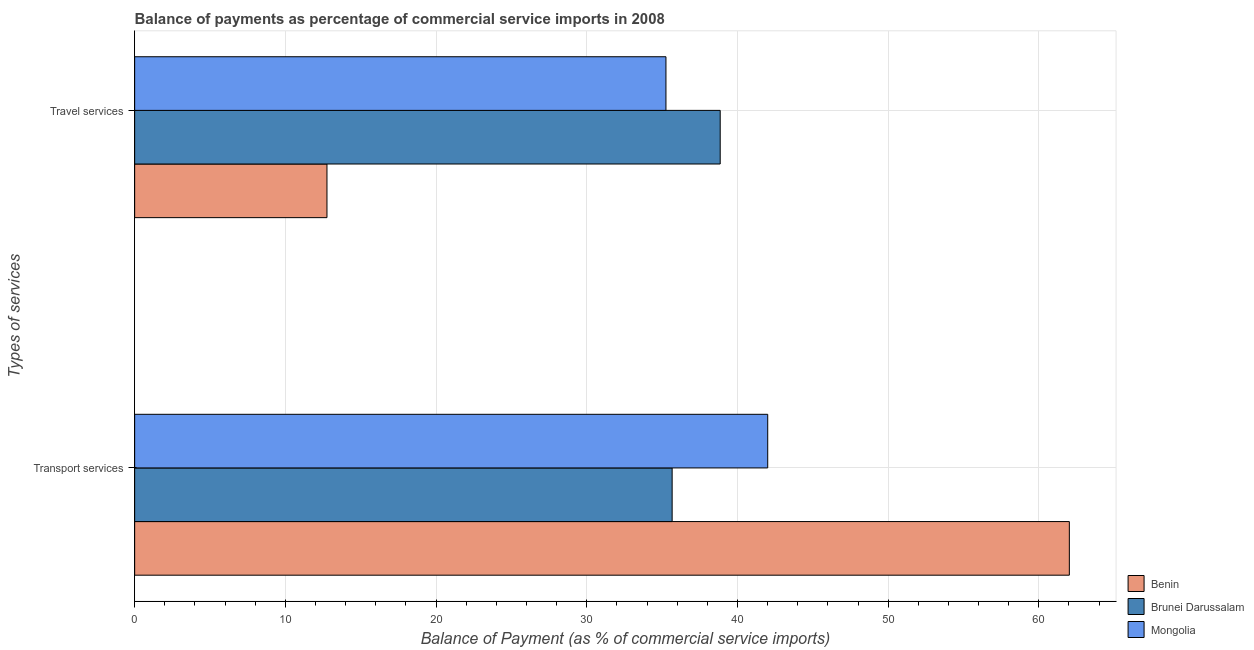Are the number of bars per tick equal to the number of legend labels?
Keep it short and to the point. Yes. How many bars are there on the 1st tick from the bottom?
Provide a short and direct response. 3. What is the label of the 1st group of bars from the top?
Offer a terse response. Travel services. What is the balance of payments of travel services in Mongolia?
Give a very brief answer. 35.26. Across all countries, what is the maximum balance of payments of travel services?
Make the answer very short. 38.86. Across all countries, what is the minimum balance of payments of transport services?
Ensure brevity in your answer.  35.67. In which country was the balance of payments of transport services maximum?
Provide a short and direct response. Benin. In which country was the balance of payments of travel services minimum?
Make the answer very short. Benin. What is the total balance of payments of transport services in the graph?
Your answer should be compact. 139.7. What is the difference between the balance of payments of transport services in Brunei Darussalam and that in Benin?
Your answer should be very brief. -26.36. What is the difference between the balance of payments of travel services in Mongolia and the balance of payments of transport services in Brunei Darussalam?
Give a very brief answer. -0.41. What is the average balance of payments of transport services per country?
Your answer should be very brief. 46.57. What is the difference between the balance of payments of transport services and balance of payments of travel services in Mongolia?
Offer a very short reply. 6.75. In how many countries, is the balance of payments of transport services greater than 42 %?
Give a very brief answer. 2. What is the ratio of the balance of payments of transport services in Mongolia to that in Brunei Darussalam?
Provide a succinct answer. 1.18. In how many countries, is the balance of payments of travel services greater than the average balance of payments of travel services taken over all countries?
Give a very brief answer. 2. What does the 1st bar from the top in Transport services represents?
Keep it short and to the point. Mongolia. What does the 2nd bar from the bottom in Travel services represents?
Offer a terse response. Brunei Darussalam. How many bars are there?
Your answer should be very brief. 6. Are the values on the major ticks of X-axis written in scientific E-notation?
Ensure brevity in your answer.  No. Does the graph contain any zero values?
Make the answer very short. No. Does the graph contain grids?
Provide a succinct answer. Yes. Where does the legend appear in the graph?
Provide a short and direct response. Bottom right. How many legend labels are there?
Ensure brevity in your answer.  3. What is the title of the graph?
Give a very brief answer. Balance of payments as percentage of commercial service imports in 2008. What is the label or title of the X-axis?
Provide a short and direct response. Balance of Payment (as % of commercial service imports). What is the label or title of the Y-axis?
Your response must be concise. Types of services. What is the Balance of Payment (as % of commercial service imports) in Benin in Transport services?
Your answer should be very brief. 62.02. What is the Balance of Payment (as % of commercial service imports) of Brunei Darussalam in Transport services?
Provide a short and direct response. 35.67. What is the Balance of Payment (as % of commercial service imports) in Mongolia in Transport services?
Provide a succinct answer. 42.01. What is the Balance of Payment (as % of commercial service imports) in Benin in Travel services?
Offer a terse response. 12.76. What is the Balance of Payment (as % of commercial service imports) of Brunei Darussalam in Travel services?
Make the answer very short. 38.86. What is the Balance of Payment (as % of commercial service imports) in Mongolia in Travel services?
Keep it short and to the point. 35.26. Across all Types of services, what is the maximum Balance of Payment (as % of commercial service imports) of Benin?
Provide a short and direct response. 62.02. Across all Types of services, what is the maximum Balance of Payment (as % of commercial service imports) of Brunei Darussalam?
Offer a terse response. 38.86. Across all Types of services, what is the maximum Balance of Payment (as % of commercial service imports) of Mongolia?
Provide a succinct answer. 42.01. Across all Types of services, what is the minimum Balance of Payment (as % of commercial service imports) of Benin?
Your answer should be compact. 12.76. Across all Types of services, what is the minimum Balance of Payment (as % of commercial service imports) of Brunei Darussalam?
Make the answer very short. 35.67. Across all Types of services, what is the minimum Balance of Payment (as % of commercial service imports) of Mongolia?
Offer a very short reply. 35.26. What is the total Balance of Payment (as % of commercial service imports) of Benin in the graph?
Your response must be concise. 74.79. What is the total Balance of Payment (as % of commercial service imports) of Brunei Darussalam in the graph?
Your response must be concise. 74.52. What is the total Balance of Payment (as % of commercial service imports) in Mongolia in the graph?
Your answer should be compact. 77.26. What is the difference between the Balance of Payment (as % of commercial service imports) in Benin in Transport services and that in Travel services?
Make the answer very short. 49.26. What is the difference between the Balance of Payment (as % of commercial service imports) in Brunei Darussalam in Transport services and that in Travel services?
Make the answer very short. -3.19. What is the difference between the Balance of Payment (as % of commercial service imports) in Mongolia in Transport services and that in Travel services?
Give a very brief answer. 6.75. What is the difference between the Balance of Payment (as % of commercial service imports) in Benin in Transport services and the Balance of Payment (as % of commercial service imports) in Brunei Darussalam in Travel services?
Your response must be concise. 23.17. What is the difference between the Balance of Payment (as % of commercial service imports) in Benin in Transport services and the Balance of Payment (as % of commercial service imports) in Mongolia in Travel services?
Provide a succinct answer. 26.77. What is the difference between the Balance of Payment (as % of commercial service imports) in Brunei Darussalam in Transport services and the Balance of Payment (as % of commercial service imports) in Mongolia in Travel services?
Keep it short and to the point. 0.41. What is the average Balance of Payment (as % of commercial service imports) of Benin per Types of services?
Provide a succinct answer. 37.39. What is the average Balance of Payment (as % of commercial service imports) in Brunei Darussalam per Types of services?
Give a very brief answer. 37.26. What is the average Balance of Payment (as % of commercial service imports) of Mongolia per Types of services?
Offer a very short reply. 38.63. What is the difference between the Balance of Payment (as % of commercial service imports) of Benin and Balance of Payment (as % of commercial service imports) of Brunei Darussalam in Transport services?
Ensure brevity in your answer.  26.36. What is the difference between the Balance of Payment (as % of commercial service imports) of Benin and Balance of Payment (as % of commercial service imports) of Mongolia in Transport services?
Make the answer very short. 20.01. What is the difference between the Balance of Payment (as % of commercial service imports) of Brunei Darussalam and Balance of Payment (as % of commercial service imports) of Mongolia in Transport services?
Provide a short and direct response. -6.34. What is the difference between the Balance of Payment (as % of commercial service imports) in Benin and Balance of Payment (as % of commercial service imports) in Brunei Darussalam in Travel services?
Provide a short and direct response. -26.09. What is the difference between the Balance of Payment (as % of commercial service imports) in Benin and Balance of Payment (as % of commercial service imports) in Mongolia in Travel services?
Your answer should be compact. -22.49. What is the difference between the Balance of Payment (as % of commercial service imports) of Brunei Darussalam and Balance of Payment (as % of commercial service imports) of Mongolia in Travel services?
Ensure brevity in your answer.  3.6. What is the ratio of the Balance of Payment (as % of commercial service imports) of Benin in Transport services to that in Travel services?
Make the answer very short. 4.86. What is the ratio of the Balance of Payment (as % of commercial service imports) of Brunei Darussalam in Transport services to that in Travel services?
Ensure brevity in your answer.  0.92. What is the ratio of the Balance of Payment (as % of commercial service imports) in Mongolia in Transport services to that in Travel services?
Offer a terse response. 1.19. What is the difference between the highest and the second highest Balance of Payment (as % of commercial service imports) of Benin?
Make the answer very short. 49.26. What is the difference between the highest and the second highest Balance of Payment (as % of commercial service imports) in Brunei Darussalam?
Offer a terse response. 3.19. What is the difference between the highest and the second highest Balance of Payment (as % of commercial service imports) in Mongolia?
Give a very brief answer. 6.75. What is the difference between the highest and the lowest Balance of Payment (as % of commercial service imports) in Benin?
Your answer should be very brief. 49.26. What is the difference between the highest and the lowest Balance of Payment (as % of commercial service imports) in Brunei Darussalam?
Offer a very short reply. 3.19. What is the difference between the highest and the lowest Balance of Payment (as % of commercial service imports) in Mongolia?
Your response must be concise. 6.75. 